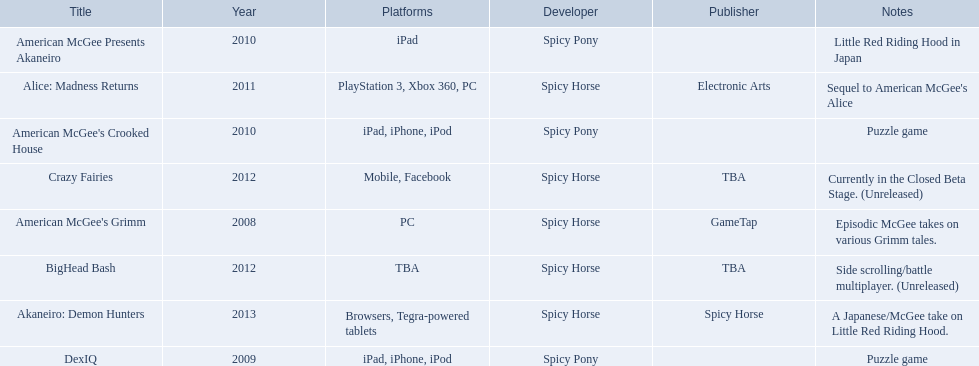What are all of the titles? American McGee's Grimm, DexIQ, American McGee Presents Akaneiro, American McGee's Crooked House, Alice: Madness Returns, BigHead Bash, Crazy Fairies, Akaneiro: Demon Hunters. Who published each title? GameTap, , , , Electronic Arts, TBA, TBA, Spicy Horse. Which game was published by electronics arts? Alice: Madness Returns. 